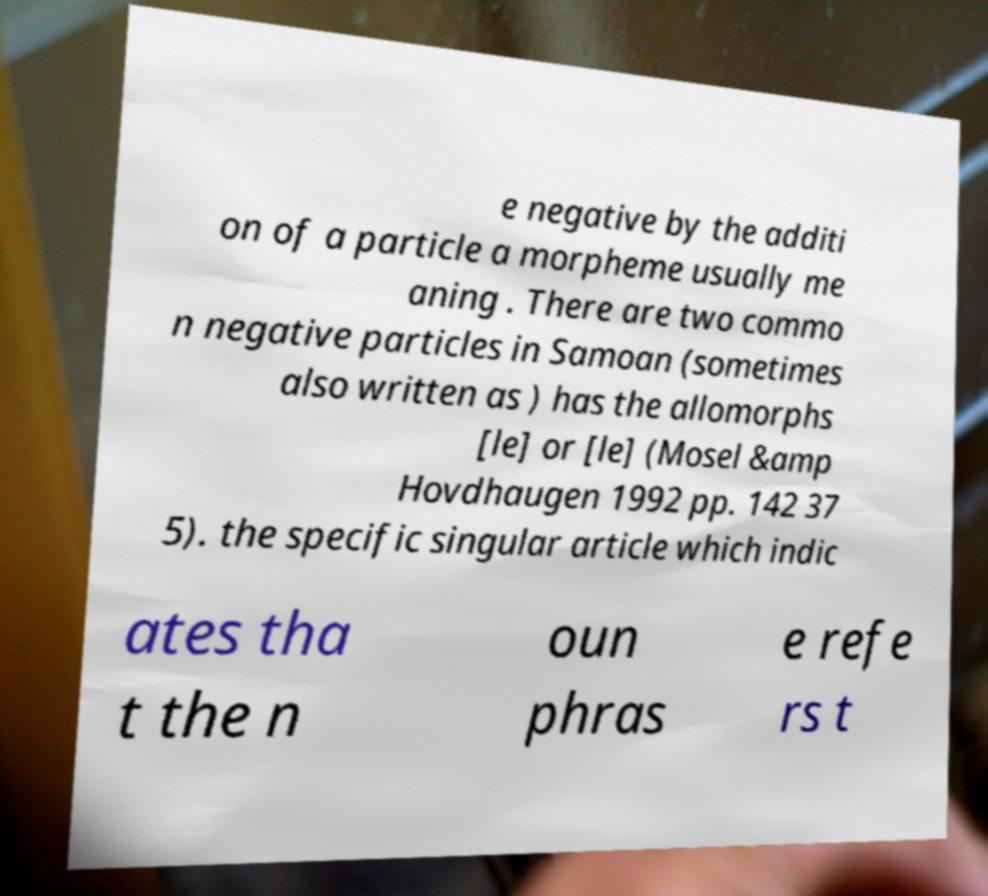Can you accurately transcribe the text from the provided image for me? e negative by the additi on of a particle a morpheme usually me aning . There are two commo n negative particles in Samoan (sometimes also written as ) has the allomorphs [le] or [le] (Mosel &amp Hovdhaugen 1992 pp. 142 37 5). the specific singular article which indic ates tha t the n oun phras e refe rs t 